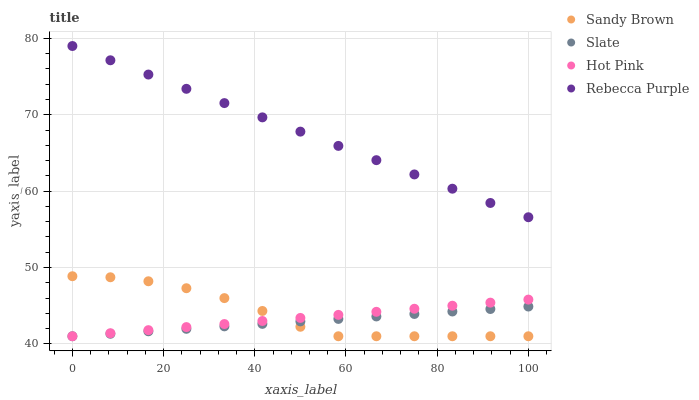Does Slate have the minimum area under the curve?
Answer yes or no. Yes. Does Rebecca Purple have the maximum area under the curve?
Answer yes or no. Yes. Does Hot Pink have the minimum area under the curve?
Answer yes or no. No. Does Hot Pink have the maximum area under the curve?
Answer yes or no. No. Is Hot Pink the smoothest?
Answer yes or no. Yes. Is Sandy Brown the roughest?
Answer yes or no. Yes. Is Sandy Brown the smoothest?
Answer yes or no. No. Is Hot Pink the roughest?
Answer yes or no. No. Does Slate have the lowest value?
Answer yes or no. Yes. Does Rebecca Purple have the lowest value?
Answer yes or no. No. Does Rebecca Purple have the highest value?
Answer yes or no. Yes. Does Hot Pink have the highest value?
Answer yes or no. No. Is Sandy Brown less than Rebecca Purple?
Answer yes or no. Yes. Is Rebecca Purple greater than Slate?
Answer yes or no. Yes. Does Hot Pink intersect Slate?
Answer yes or no. Yes. Is Hot Pink less than Slate?
Answer yes or no. No. Is Hot Pink greater than Slate?
Answer yes or no. No. Does Sandy Brown intersect Rebecca Purple?
Answer yes or no. No. 